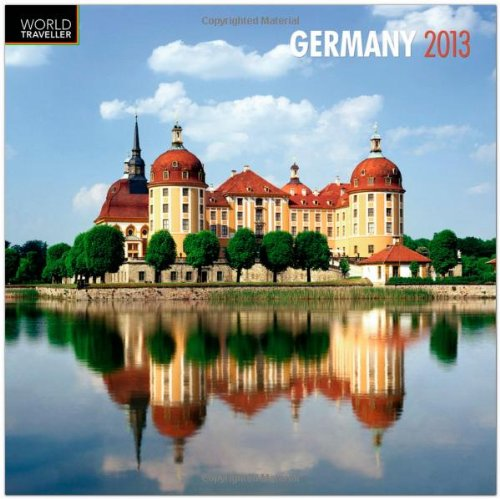Is this book related to Calendars? Absolutely, this is indeed a wall calendar, a tool commonly used to keep track of days, featuring scenic imagery from Germany. 